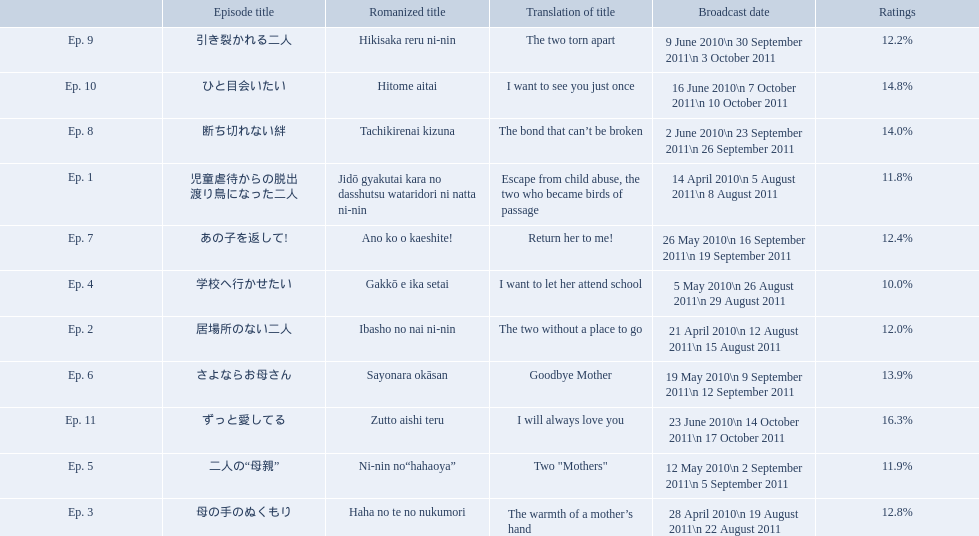What as the percentage total of ratings for episode 8? 14.0%. 